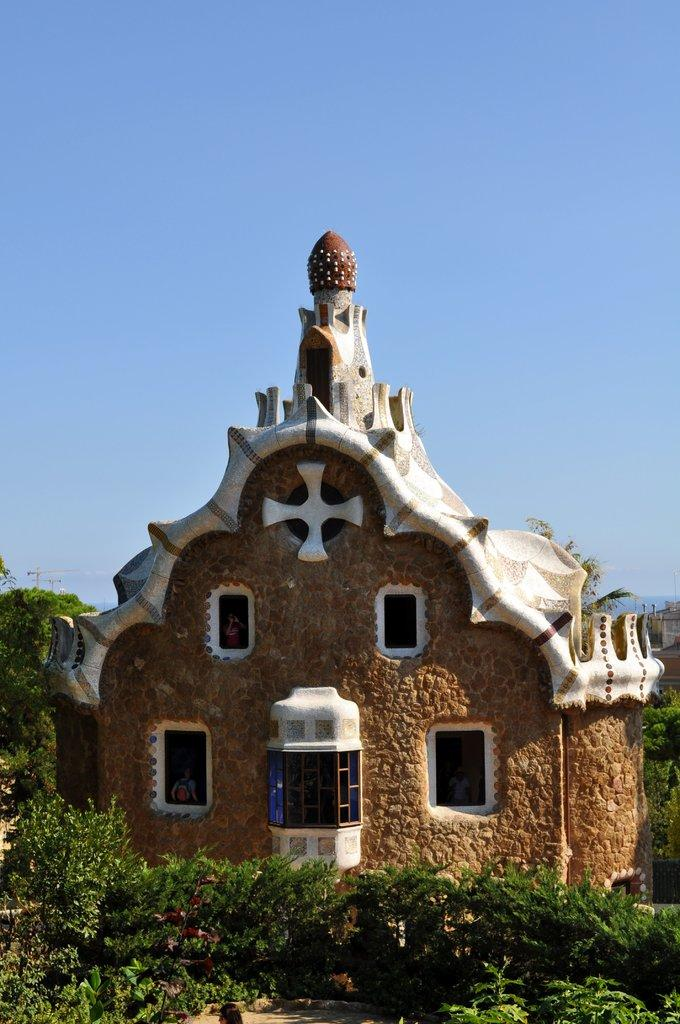What is located in the front of the image? There are plants in the front of the image. What can be seen behind the plants? There is a building visible behind the plants. What type of vegetation is in the background of the image? There are trees in the background of the image. What is visible in the background of the image besides the trees? The sky is visible in the background of the image. What type of theory is being tested with the apparatus in the image? There is no apparatus or theory present in the image; it features plants, a building, trees, and the sky. 